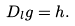Convert formula to latex. <formula><loc_0><loc_0><loc_500><loc_500>D _ { l } g = h .</formula> 